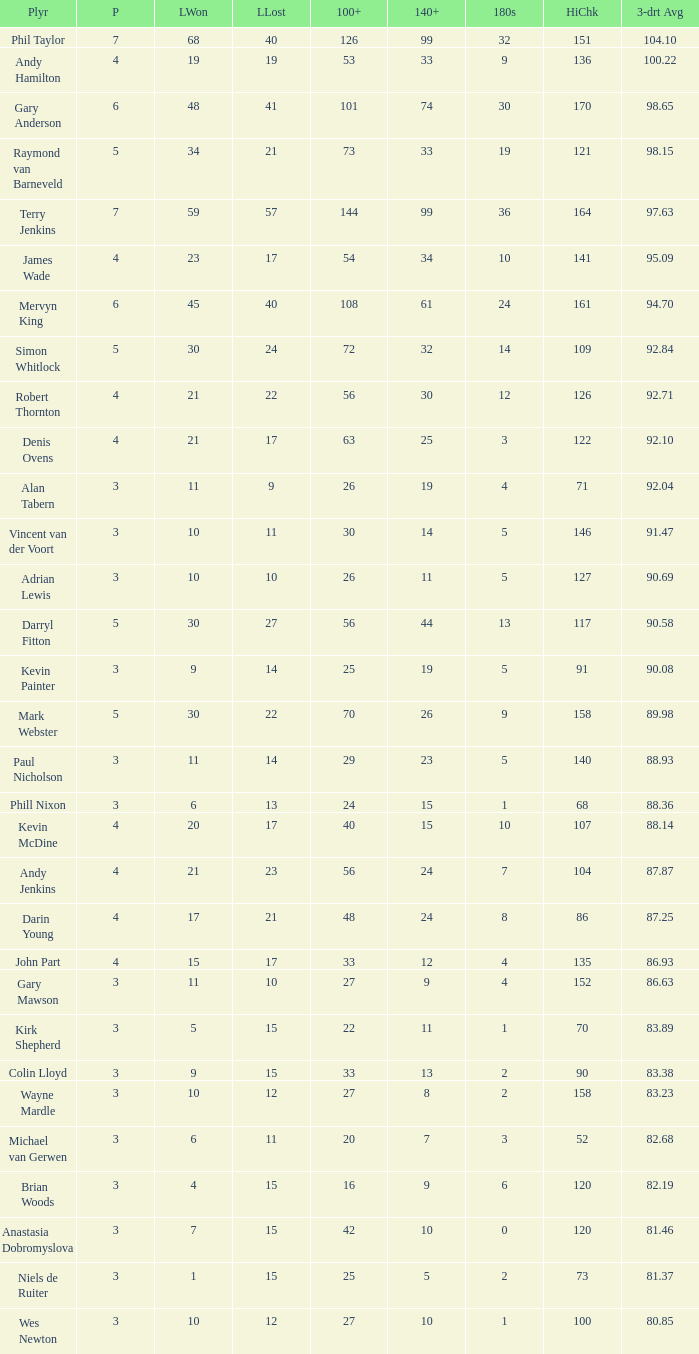Write the full table. {'header': ['Plyr', 'P', 'LWon', 'LLost', '100+', '140+', '180s', 'HiChk', '3-drt Avg'], 'rows': [['Phil Taylor', '7', '68', '40', '126', '99', '32', '151', '104.10'], ['Andy Hamilton', '4', '19', '19', '53', '33', '9', '136', '100.22'], ['Gary Anderson', '6', '48', '41', '101', '74', '30', '170', '98.65'], ['Raymond van Barneveld', '5', '34', '21', '73', '33', '19', '121', '98.15'], ['Terry Jenkins', '7', '59', '57', '144', '99', '36', '164', '97.63'], ['James Wade', '4', '23', '17', '54', '34', '10', '141', '95.09'], ['Mervyn King', '6', '45', '40', '108', '61', '24', '161', '94.70'], ['Simon Whitlock', '5', '30', '24', '72', '32', '14', '109', '92.84'], ['Robert Thornton', '4', '21', '22', '56', '30', '12', '126', '92.71'], ['Denis Ovens', '4', '21', '17', '63', '25', '3', '122', '92.10'], ['Alan Tabern', '3', '11', '9', '26', '19', '4', '71', '92.04'], ['Vincent van der Voort', '3', '10', '11', '30', '14', '5', '146', '91.47'], ['Adrian Lewis', '3', '10', '10', '26', '11', '5', '127', '90.69'], ['Darryl Fitton', '5', '30', '27', '56', '44', '13', '117', '90.58'], ['Kevin Painter', '3', '9', '14', '25', '19', '5', '91', '90.08'], ['Mark Webster', '5', '30', '22', '70', '26', '9', '158', '89.98'], ['Paul Nicholson', '3', '11', '14', '29', '23', '5', '140', '88.93'], ['Phill Nixon', '3', '6', '13', '24', '15', '1', '68', '88.36'], ['Kevin McDine', '4', '20', '17', '40', '15', '10', '107', '88.14'], ['Andy Jenkins', '4', '21', '23', '56', '24', '7', '104', '87.87'], ['Darin Young', '4', '17', '21', '48', '24', '8', '86', '87.25'], ['John Part', '4', '15', '17', '33', '12', '4', '135', '86.93'], ['Gary Mawson', '3', '11', '10', '27', '9', '4', '152', '86.63'], ['Kirk Shepherd', '3', '5', '15', '22', '11', '1', '70', '83.89'], ['Colin Lloyd', '3', '9', '15', '33', '13', '2', '90', '83.38'], ['Wayne Mardle', '3', '10', '12', '27', '8', '2', '158', '83.23'], ['Michael van Gerwen', '3', '6', '11', '20', '7', '3', '52', '82.68'], ['Brian Woods', '3', '4', '15', '16', '9', '6', '120', '82.19'], ['Anastasia Dobromyslova', '3', '7', '15', '42', '10', '0', '120', '81.46'], ['Niels de Ruiter', '3', '1', '15', '25', '5', '2', '73', '81.37'], ['Wes Newton', '3', '10', '12', '27', '10', '1', '100', '80.85']]} What is the most legs lost of all? 57.0. 